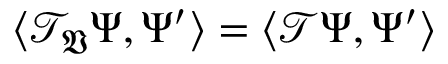<formula> <loc_0><loc_0><loc_500><loc_500>\langle \mathcal { T } _ { \mathfrak { V } } \Psi , \Psi ^ { \prime } \rangle = \langle \mathcal { T } \Psi , \Psi ^ { \prime } \rangle</formula> 